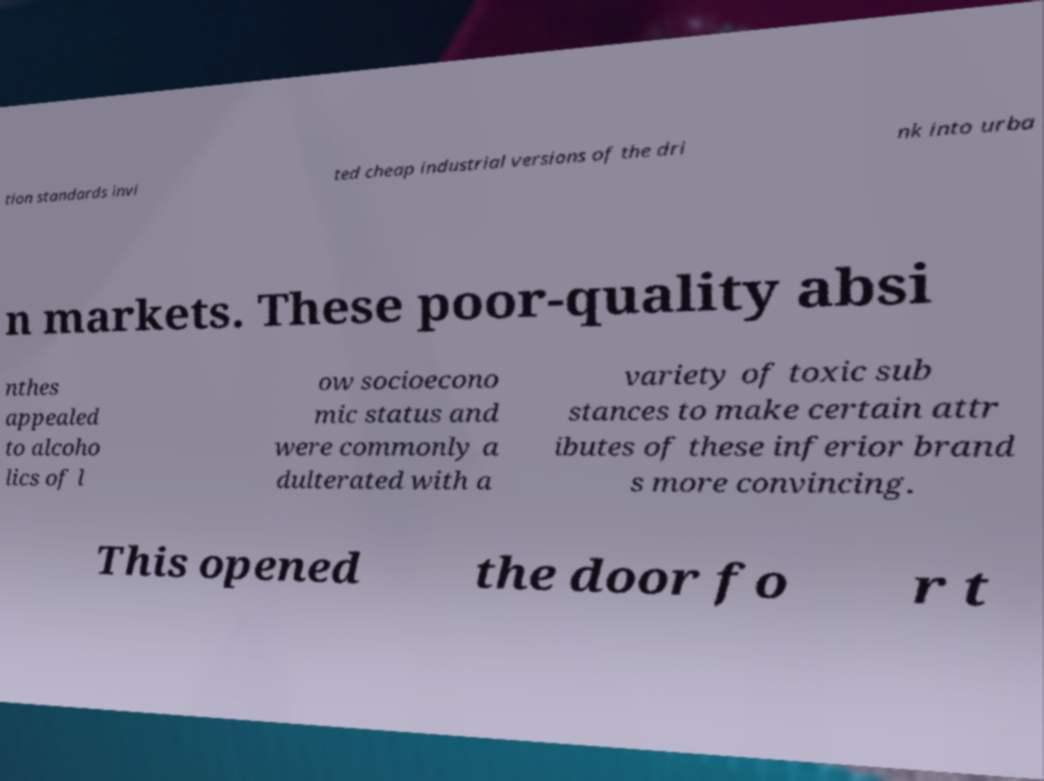Can you accurately transcribe the text from the provided image for me? tion standards invi ted cheap industrial versions of the dri nk into urba n markets. These poor-quality absi nthes appealed to alcoho lics of l ow socioecono mic status and were commonly a dulterated with a variety of toxic sub stances to make certain attr ibutes of these inferior brand s more convincing. This opened the door fo r t 